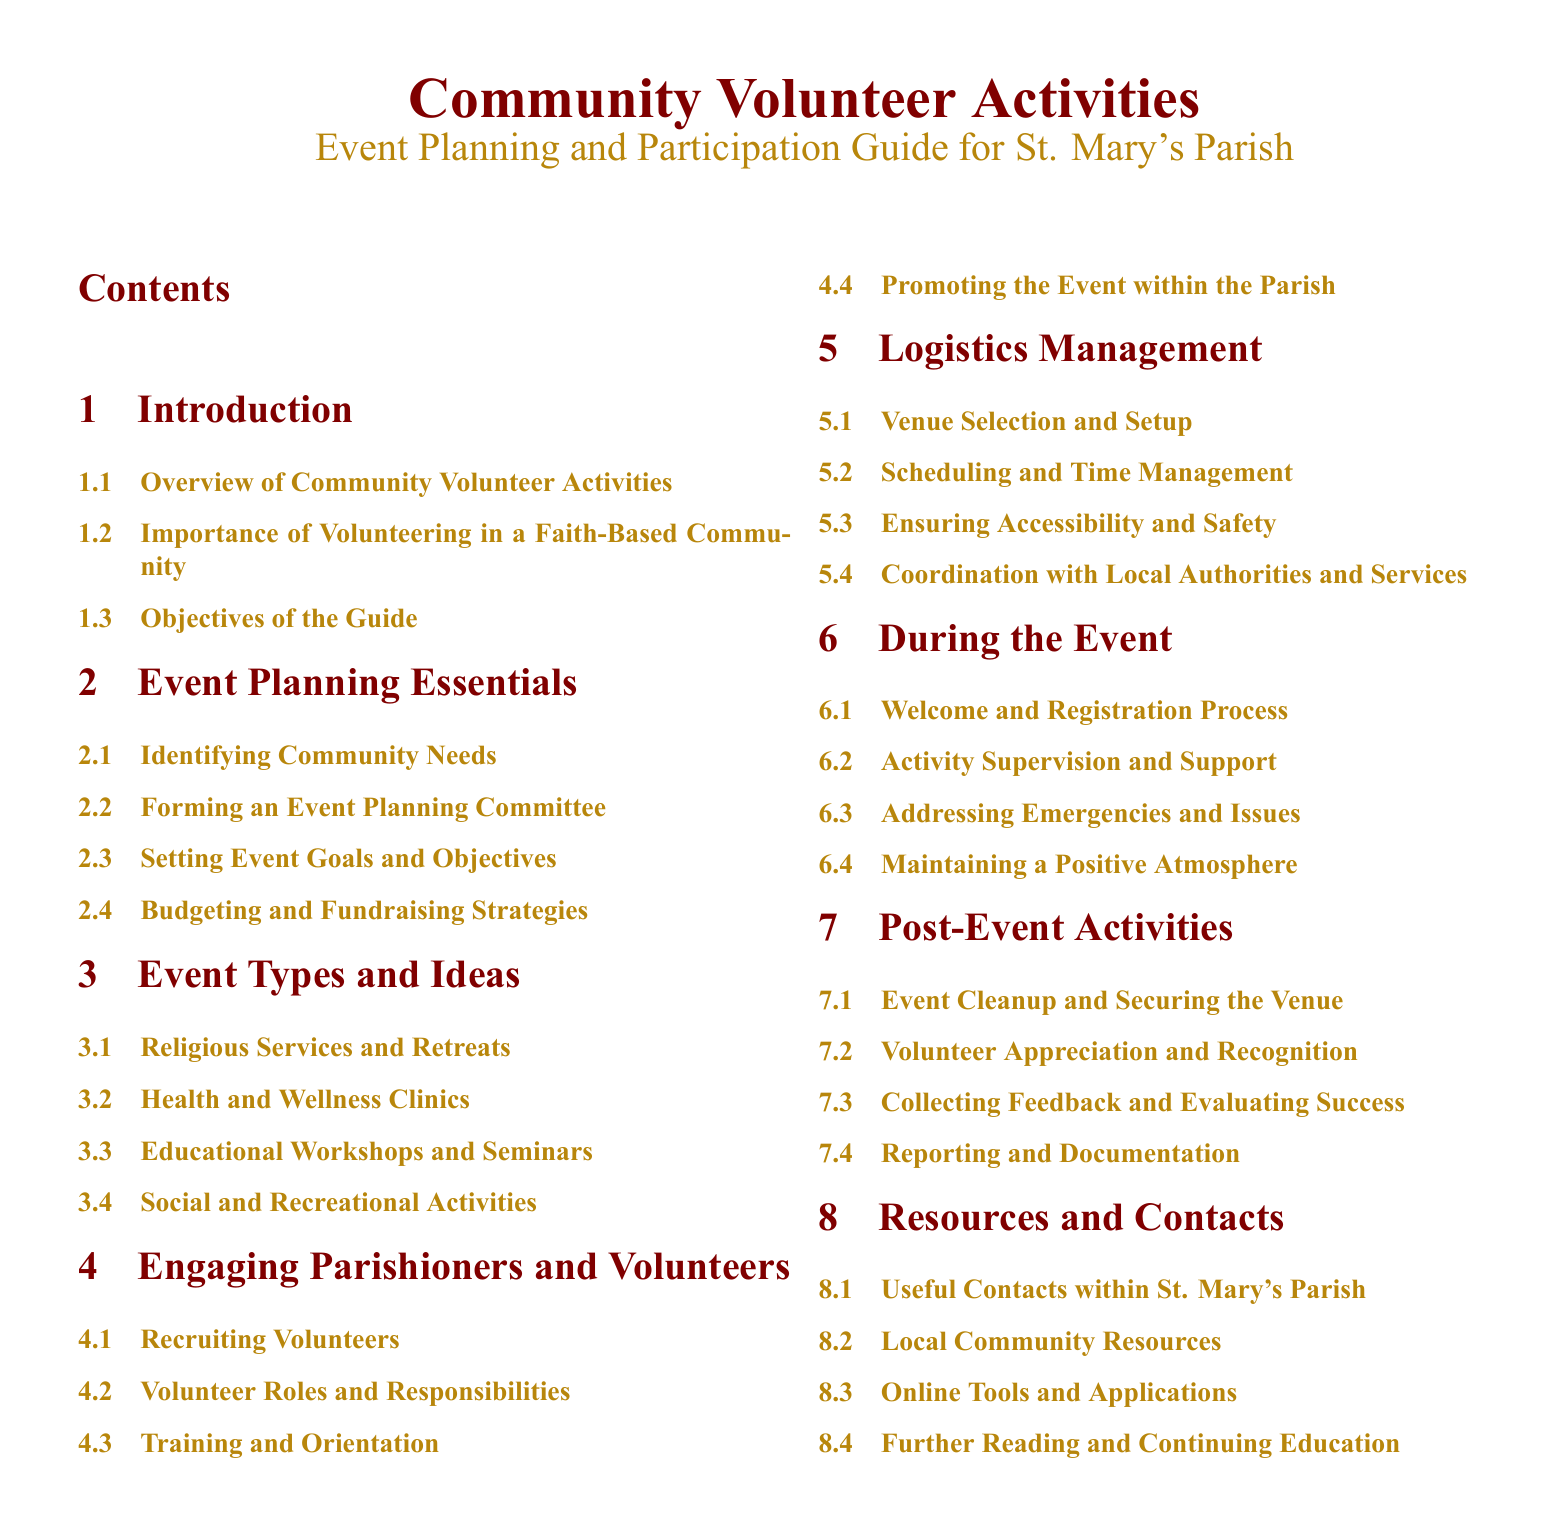what is the title of the document? The title of the document is prominently displayed at the top of the first page.
Answer: Community Volunteer Activities what is the primary focus of section 2? Section 2 is dedicated to the essentials needed for planning events, aiming to guide volunteers effectively.
Answer: Event Planning Essentials how many sub-sections are listed under "Engaging Parishioners and Volunteers"? This question looks for a count of the sub-sections under the specified section.
Answer: 4 what is the color of the section titles? The section titles are styled in a specific color, which is indicated in the document formatting.
Answer: maroon which section focuses on evaluating the success of an event? The section that deals with evaluating past events and gathering feedback is crucial for improving future activities.
Answer: Post-Event Activities what are two types of events mentioned in the document? This question calls for examples of event types identified in the document.
Answer: Health and Wellness Clinics, Educational Workshops what is the purpose of the "Resources and Contacts" section? This section aims to provide useful information for volunteers and parish leaders to facilitate community activities.
Answer: Useful Contacts within St. Mary's Parish how many main sections are included in the table of contents? Counting the main sections gives insight into the document’s structure and organization.
Answer: 8 what is the color used for the subsection titles? The subsection titles are formatted in a distinct color specified within the document.
Answer: gold 